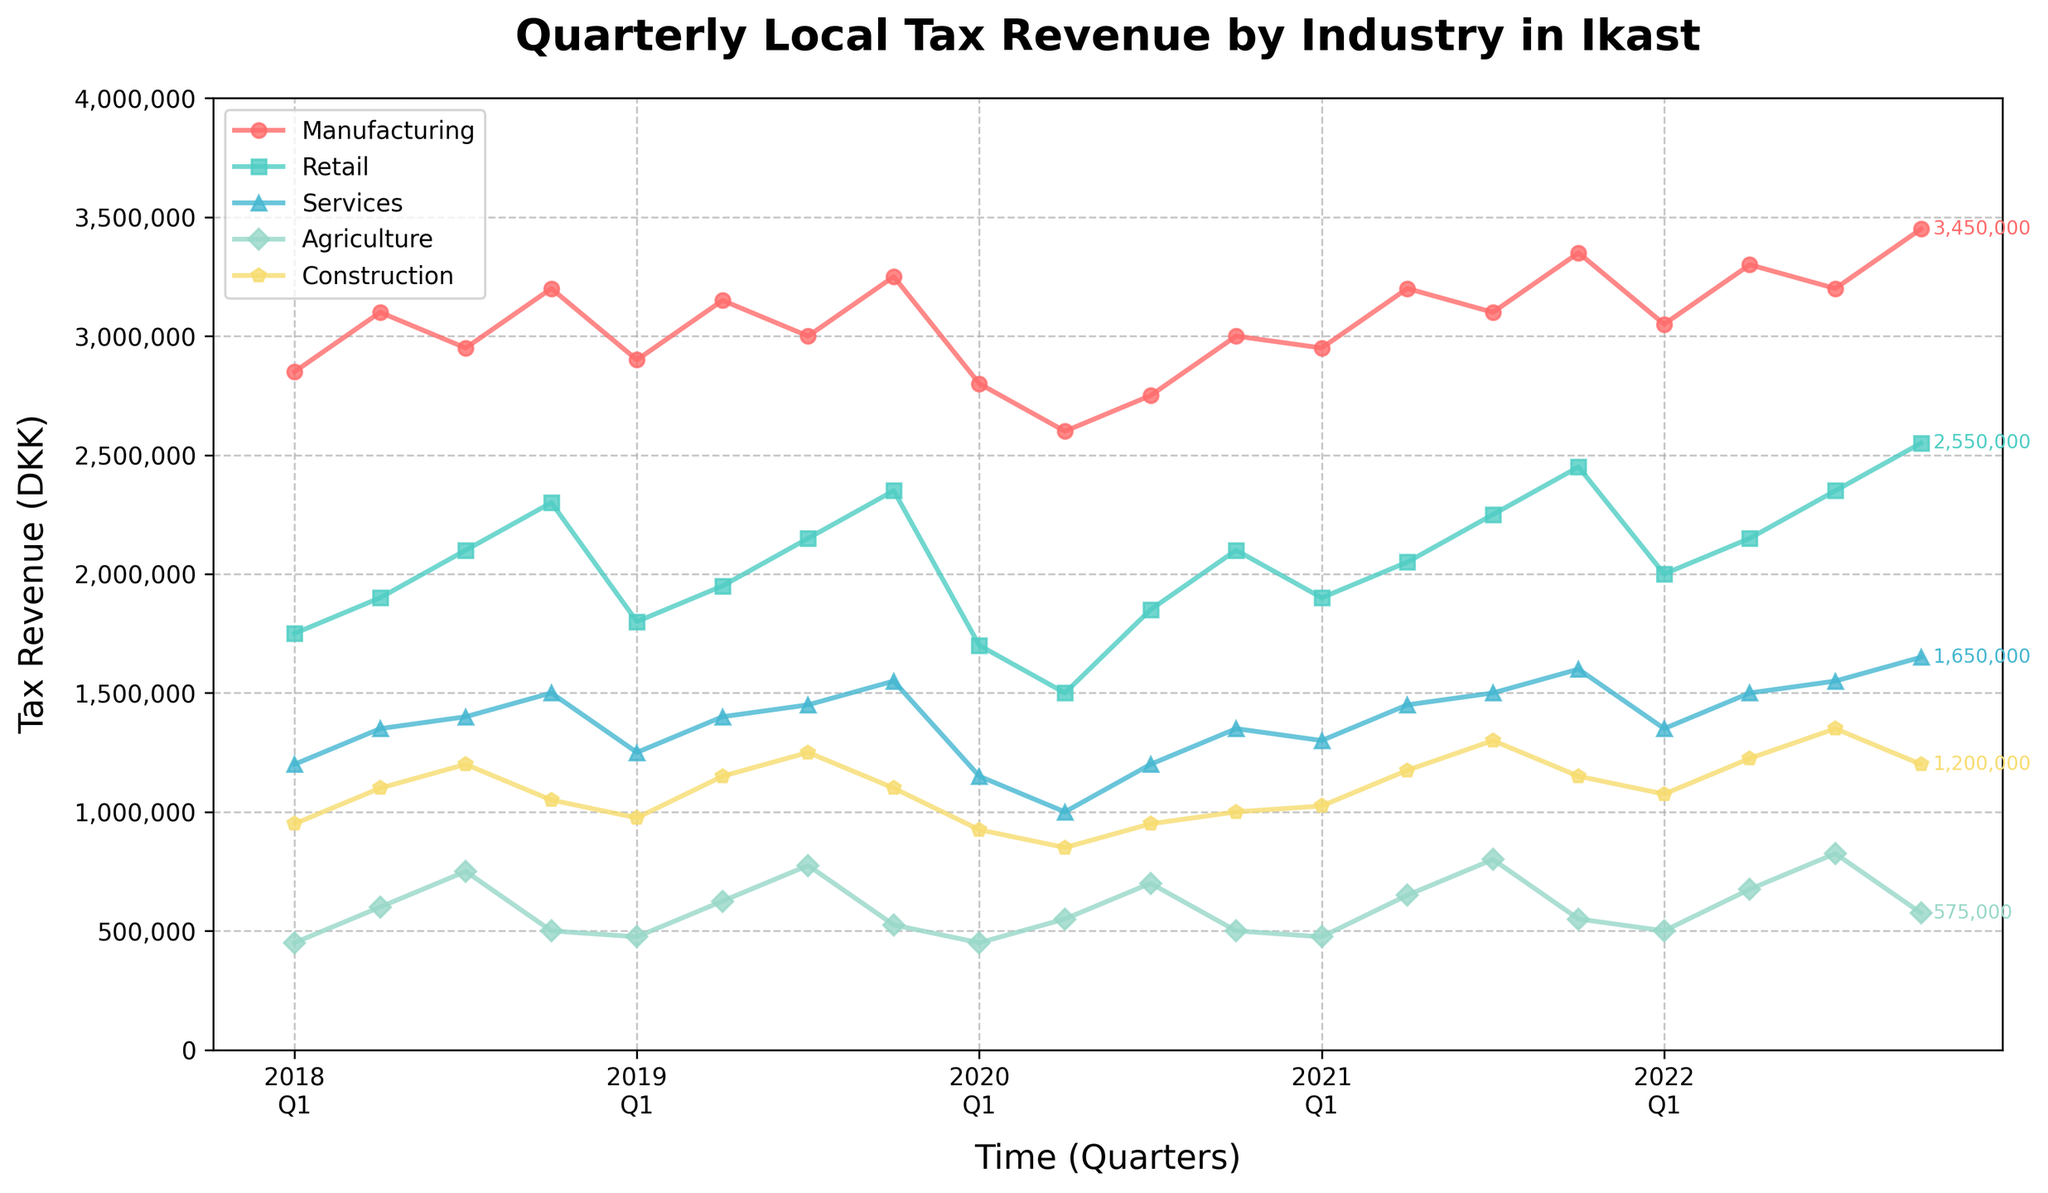What was the highest quarterly tax revenue for the Manufacturing industry, and when did it occur? Observe the line for the Manufacturing industry. The highest point is approximately DKK 3,450,000 in Q4 of 2022.
Answer: DKK 3,450,000 in Q4 2022 Which industry experienced the most significant drop in tax revenue during the period shown? Examine the lines for each industry to identify sudden declines. The Retail industry experienced a notable drop around 2020 Q2 from DKK 1,850,000 to DKK 1,500,000.
Answer: Retail What was the total tax revenue for the Services industry in 2021? Sum the values for the Services industry in 2021: 1,300,000 (Q1) + 1,450,000 (Q2) + 1,500,000 (Q3) + 1,600,000 (Q4) = DKK 5,850,000.
Answer: DKK 5,850,000 How does the average quarterly tax revenue of the Retail industry in 2019 compare to the same industry's average in 2020? Calculate the average for each year: 2019 (1,800,000+1,950,000+2,150,000+2,350,000)/4 = DKK 2,062,500; 2020 (1,700,000+1,500,000+1,850,000+2,100,000)/4 = DKK 1,787,500. Compare the two averages.
Answer: 2019: DKK 2,062,500, 2020: DKK 1,787,500 Which two quarters in different years had the same tax revenue amount for the Construction industry? Compare the values for the Construction industry across different quarters. Q1 2021 and Q4 2020 both show DKK 1,025,000.
Answer: Q4 2020 and Q1 2021 What's the change in tax revenue for the Agriculture industry from Q1 2018 to Q1 2019? Subtract the Q1 2018 value from the Q1 2019 value: 475,000 (Q1 2019) - 450,000 (Q1 2018) = DKK 25,000.
Answer: DKK 25,000 Which industry displayed the least variance in tax revenue over the five-year period? Evaluate how much each industry's line fluctuates over time. The Agriculture industry has the least fluctuation compared to others.
Answer: Agriculture What is the percentage increase in tax revenue for the Agriculture industry from Q1 2022 to Q3 2022? Calculate the percentage increase: ((825,000 - 500,000) / 500,000) * 100 = 65%.
Answer: 65% By how much did the Manufacturing tax revenue increase from Q3 2020 to Q3 2021? Subtract Q3 2020 value from Q3 2021 value: 3,100,000 (Q3 2021) - 2,750,000 (Q3 2020) = DKK 350,000.
Answer: DKK 350,000 